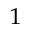<formula> <loc_0><loc_0><loc_500><loc_500>^ { 1 }</formula> 